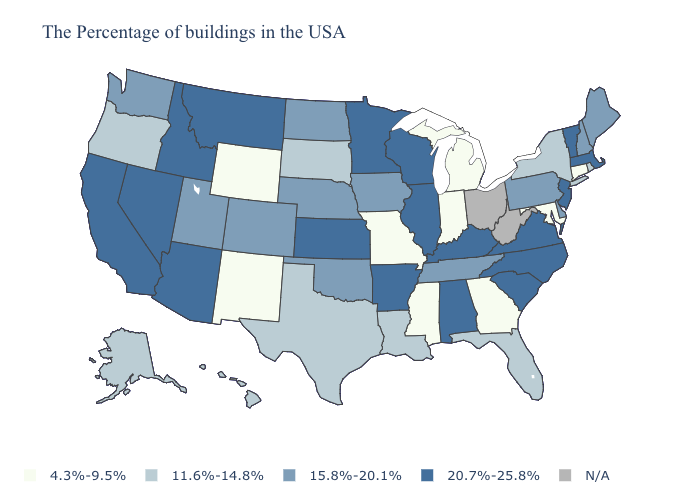What is the lowest value in states that border Maryland?
Write a very short answer. 15.8%-20.1%. What is the highest value in states that border Alabama?
Give a very brief answer. 15.8%-20.1%. What is the highest value in the USA?
Give a very brief answer. 20.7%-25.8%. Among the states that border North Carolina , does South Carolina have the lowest value?
Concise answer only. No. Name the states that have a value in the range N/A?
Short answer required. West Virginia, Ohio. Among the states that border Idaho , which have the lowest value?
Short answer required. Wyoming. Does Virginia have the highest value in the USA?
Give a very brief answer. Yes. Which states hav the highest value in the Northeast?
Be succinct. Massachusetts, Vermont, New Jersey. Name the states that have a value in the range 4.3%-9.5%?
Give a very brief answer. Connecticut, Maryland, Georgia, Michigan, Indiana, Mississippi, Missouri, Wyoming, New Mexico. Does the map have missing data?
Give a very brief answer. Yes. Name the states that have a value in the range 15.8%-20.1%?
Be succinct. Maine, New Hampshire, Delaware, Pennsylvania, Tennessee, Iowa, Nebraska, Oklahoma, North Dakota, Colorado, Utah, Washington. What is the lowest value in states that border Oregon?
Keep it brief. 15.8%-20.1%. Does North Carolina have the highest value in the USA?
Short answer required. Yes. 